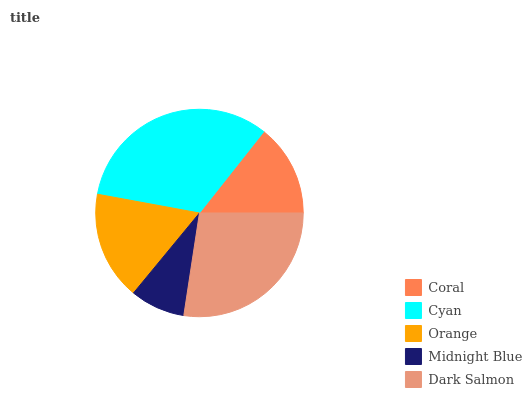Is Midnight Blue the minimum?
Answer yes or no. Yes. Is Cyan the maximum?
Answer yes or no. Yes. Is Orange the minimum?
Answer yes or no. No. Is Orange the maximum?
Answer yes or no. No. Is Cyan greater than Orange?
Answer yes or no. Yes. Is Orange less than Cyan?
Answer yes or no. Yes. Is Orange greater than Cyan?
Answer yes or no. No. Is Cyan less than Orange?
Answer yes or no. No. Is Orange the high median?
Answer yes or no. Yes. Is Orange the low median?
Answer yes or no. Yes. Is Midnight Blue the high median?
Answer yes or no. No. Is Cyan the low median?
Answer yes or no. No. 